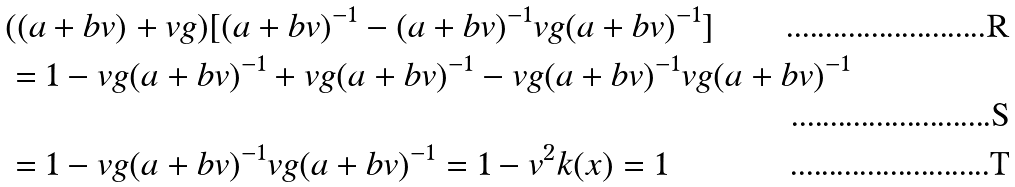Convert formula to latex. <formula><loc_0><loc_0><loc_500><loc_500>& ( ( a + b v ) + v g ) [ ( a + b v ) ^ { - 1 } - ( a + b v ) ^ { - 1 } v g ( a + b v ) ^ { - 1 } ] \\ & = 1 - v g ( a + b v ) ^ { - 1 } + v g ( a + b v ) ^ { - 1 } - v g ( a + b v ) ^ { - 1 } v g ( a + b v ) ^ { - 1 } \\ & = 1 - v g ( a + b v ) ^ { - 1 } v g ( a + b v ) ^ { - 1 } = 1 - v ^ { 2 } k ( x ) = 1</formula> 